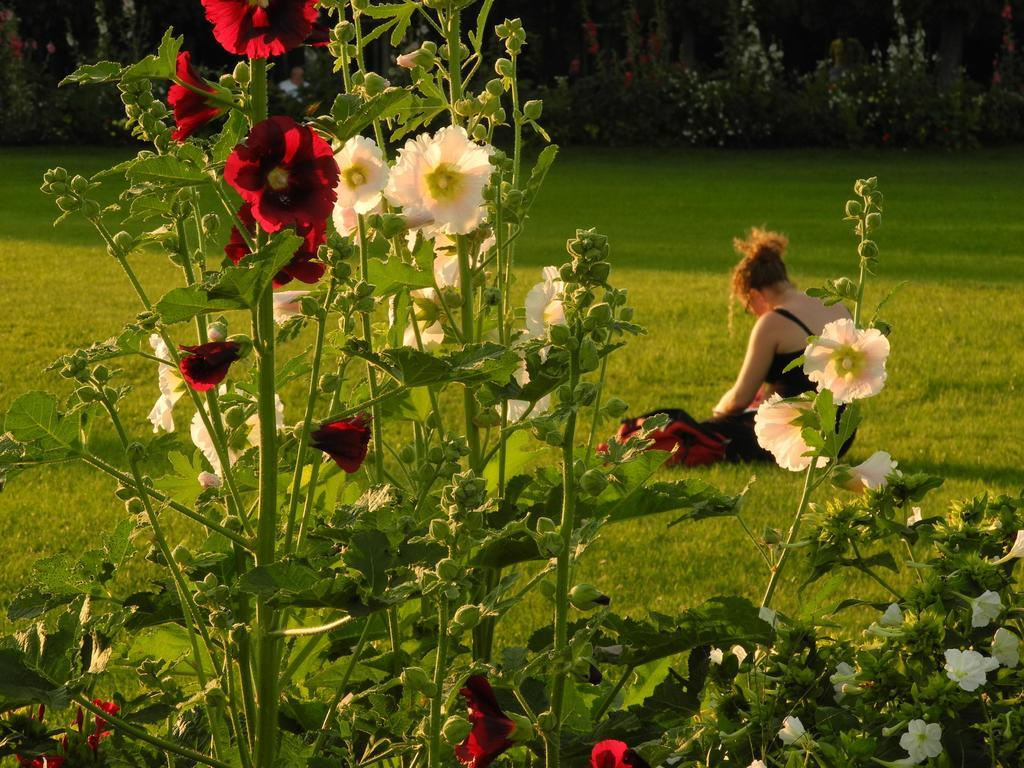What type of vegetation can be seen in the image? There is a group of plants and flowers in the image. Can you describe the person visible behind the plants? Unfortunately, the person is not clearly visible, but we know that there is a person behind the plants. What type of ground cover is present in the image? Grass is present in the image. What else can be seen in the background of the image? There is a group of plants in the background of the image. What is the name of the list that the person is holding in the image? There is no list present in the image, and the person is not holding anything. 